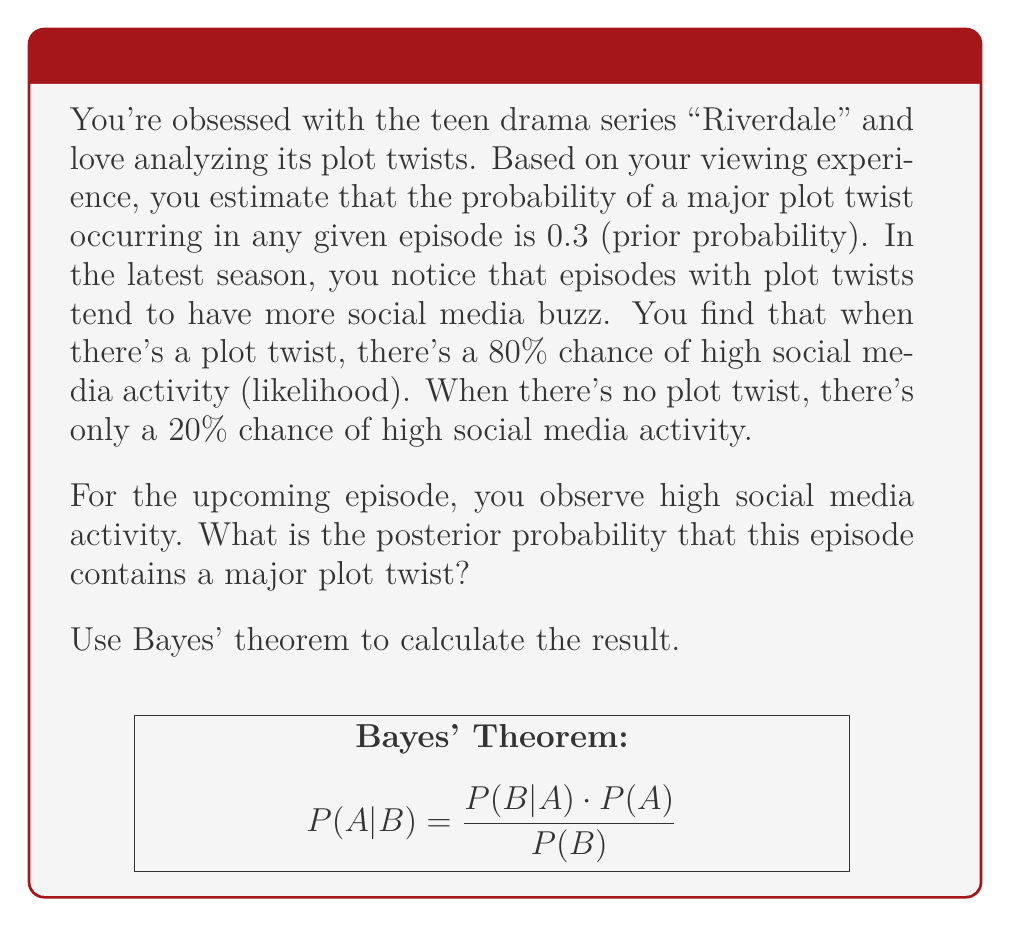Could you help me with this problem? Let's approach this step-by-step using Bayes' theorem:

1) Define our events:
   A: The episode contains a major plot twist
   B: High social media activity is observed

2) Given information:
   P(A) = 0.3 (prior probability of a plot twist)
   P(B|A) = 0.8 (likelihood of high social media activity given a plot twist)
   P(B|not A) = 0.2 (likelihood of high social media activity given no plot twist)

3) Bayes' theorem states:

   $$P(A|B) = \frac{P(B|A) \cdot P(A)}{P(B)}$$

4) We need to calculate P(B) using the law of total probability:

   $$P(B) = P(B|A) \cdot P(A) + P(B|not A) \cdot P(not A)$$
   $$P(B) = 0.8 \cdot 0.3 + 0.2 \cdot 0.7 = 0.24 + 0.14 = 0.38$$

5) Now we can apply Bayes' theorem:

   $$P(A|B) = \frac{0.8 \cdot 0.3}{0.38} = \frac{0.24}{0.38} \approx 0.6316$$

6) Convert to a percentage:
   0.6316 * 100% ≈ 63.16%

Therefore, given the high social media activity, the posterior probability of a major plot twist in this episode is approximately 63.16%.
Answer: 63.16% 